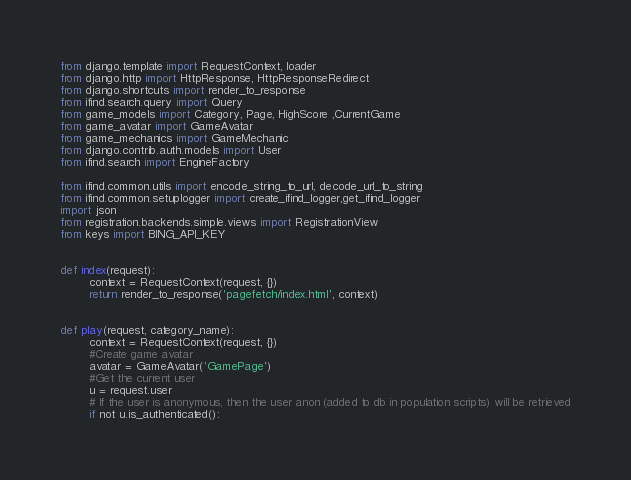Convert code to text. <code><loc_0><loc_0><loc_500><loc_500><_Python_>from django.template import RequestContext, loader
from django.http import HttpResponse, HttpResponseRedirect
from django.shortcuts import render_to_response
from ifind.search.query import Query
from game_models import Category, Page, HighScore ,CurrentGame
from game_avatar import GameAvatar
from game_mechanics import GameMechanic
from django.contrib.auth.models import User
from ifind.search import EngineFactory

from ifind.common.utils import encode_string_to_url, decode_url_to_string
from ifind.common.setuplogger import create_ifind_logger,get_ifind_logger
import json
from registration.backends.simple.views import RegistrationView
from keys import BING_API_KEY


def index(request):
        context = RequestContext(request, {})
        return render_to_response('pagefetch/index.html', context)


def play(request, category_name):
        context = RequestContext(request, {})
        #Create game avatar
        avatar = GameAvatar('GamePage')
        #Get the current user
        u = request.user
        # If the user is anonymous, then the user anon (added to db in population scripts) will be retrieved
        if not u.is_authenticated():</code> 